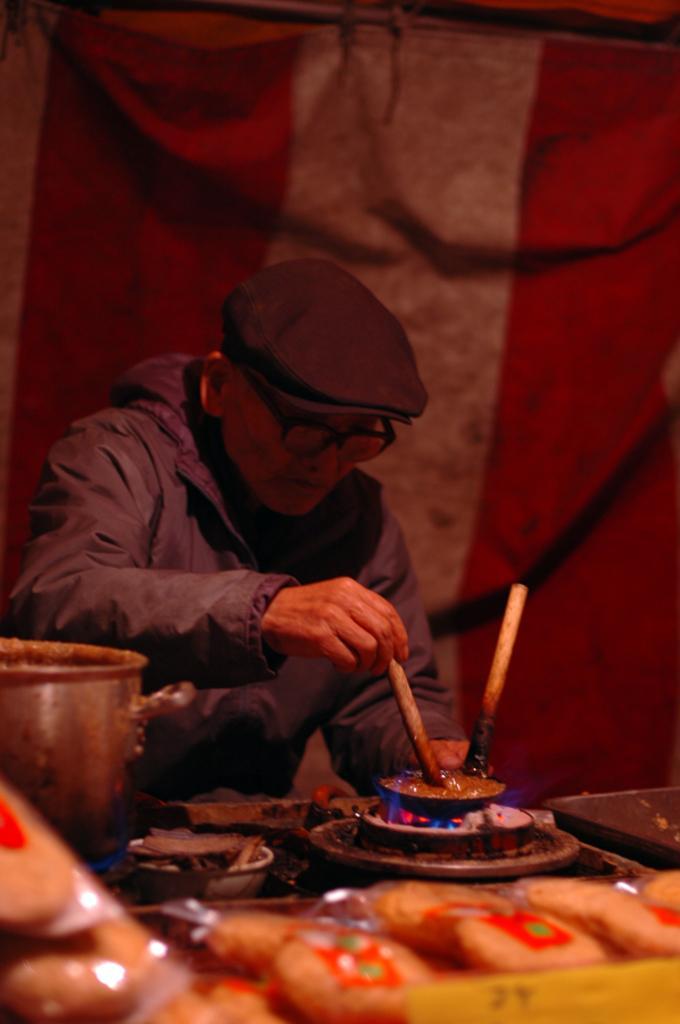How would you summarize this image in a sentence or two? In this picture we can see a person wore a cap and spectacles. In front of this person we can see a gas stove, bowls and some objects. In the background we can see a cloth. 